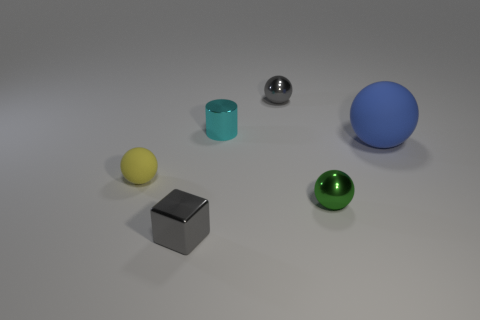There is a sphere on the left side of the gray object that is behind the big blue matte ball; what is it made of?
Give a very brief answer. Rubber. How many small objects are either yellow things or blue spheres?
Offer a very short reply. 1. How big is the blue rubber thing?
Offer a terse response. Large. Are there more tiny metallic cylinders that are behind the big blue matte object than brown metallic cylinders?
Your answer should be very brief. Yes. Are there an equal number of gray metallic cubes behind the blue object and small things that are left of the small green shiny sphere?
Ensure brevity in your answer.  No. The tiny ball that is both in front of the big rubber object and on the right side of the tiny rubber sphere is what color?
Make the answer very short. Green. Is there any other thing that is the same size as the yellow matte object?
Keep it short and to the point. Yes. Are there more blue rubber things that are in front of the gray metallic cube than small yellow things left of the tiny rubber sphere?
Your response must be concise. No. There is a gray thing that is right of the metal cube; is it the same size as the small green shiny ball?
Keep it short and to the point. Yes. What number of tiny metallic things are in front of the small gray thing that is behind the gray metal thing that is in front of the large rubber thing?
Your answer should be very brief. 3. 